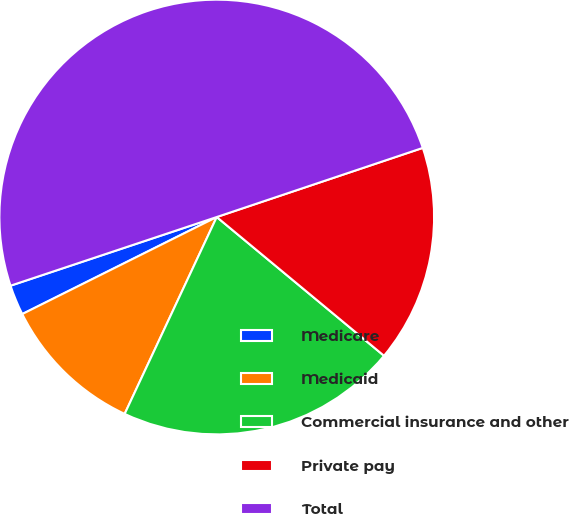Convert chart. <chart><loc_0><loc_0><loc_500><loc_500><pie_chart><fcel>Medicare<fcel>Medicaid<fcel>Commercial insurance and other<fcel>Private pay<fcel>Total<nl><fcel>2.25%<fcel>10.67%<fcel>20.94%<fcel>16.17%<fcel>49.96%<nl></chart> 